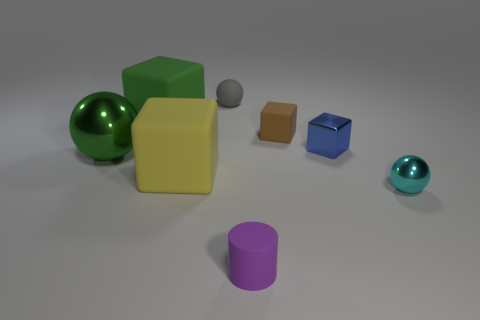Is there a yellow thing that is in front of the tiny rubber thing that is in front of the cyan metal ball?
Provide a succinct answer. No. Is the color of the big cube that is behind the small blue metallic block the same as the metallic ball that is to the left of the small brown thing?
Your answer should be compact. Yes. What number of brown cubes are behind the rubber ball?
Provide a short and direct response. 0. What number of spheres are the same color as the small metal cube?
Offer a terse response. 0. Do the tiny ball that is to the right of the purple matte thing and the tiny gray thing have the same material?
Provide a succinct answer. No. How many brown objects are made of the same material as the brown block?
Offer a terse response. 0. Are there more tiny rubber things in front of the green block than brown blocks?
Your answer should be very brief. Yes. There is a block that is the same color as the big sphere; what size is it?
Provide a short and direct response. Large. Is there a tiny purple matte thing of the same shape as the brown object?
Provide a short and direct response. No. What number of objects are either small cyan metallic spheres or tiny purple metallic balls?
Your answer should be very brief. 1. 